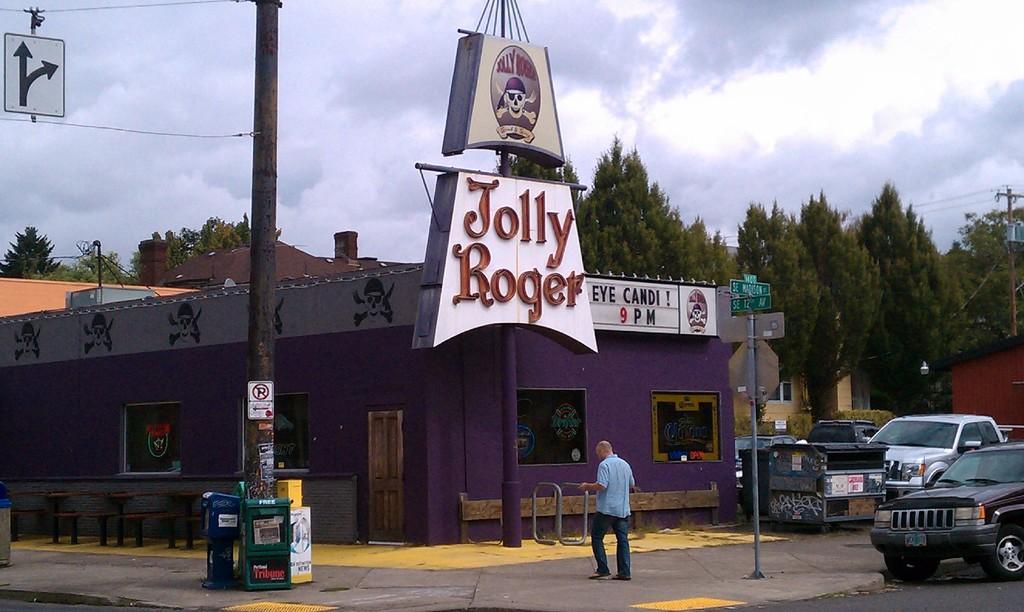Describe this image in one or two sentences. In this image we can see few buildings, a building with boards and there are poles with sign boards, there are few tables and benches near the building, there are boxes near the pole and a box near the vehicles on the road, a person holding an object, there is a pole with wires and there are few trees and the sky with clouds in the background. 